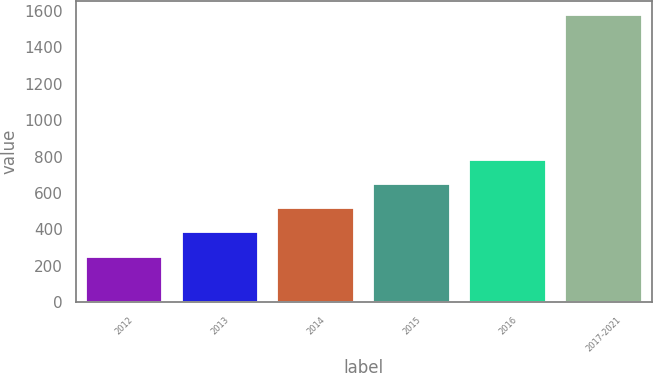Convert chart to OTSL. <chart><loc_0><loc_0><loc_500><loc_500><bar_chart><fcel>2012<fcel>2013<fcel>2014<fcel>2015<fcel>2016<fcel>2017-2021<nl><fcel>251<fcel>383.7<fcel>516.4<fcel>649.1<fcel>781.8<fcel>1578<nl></chart> 